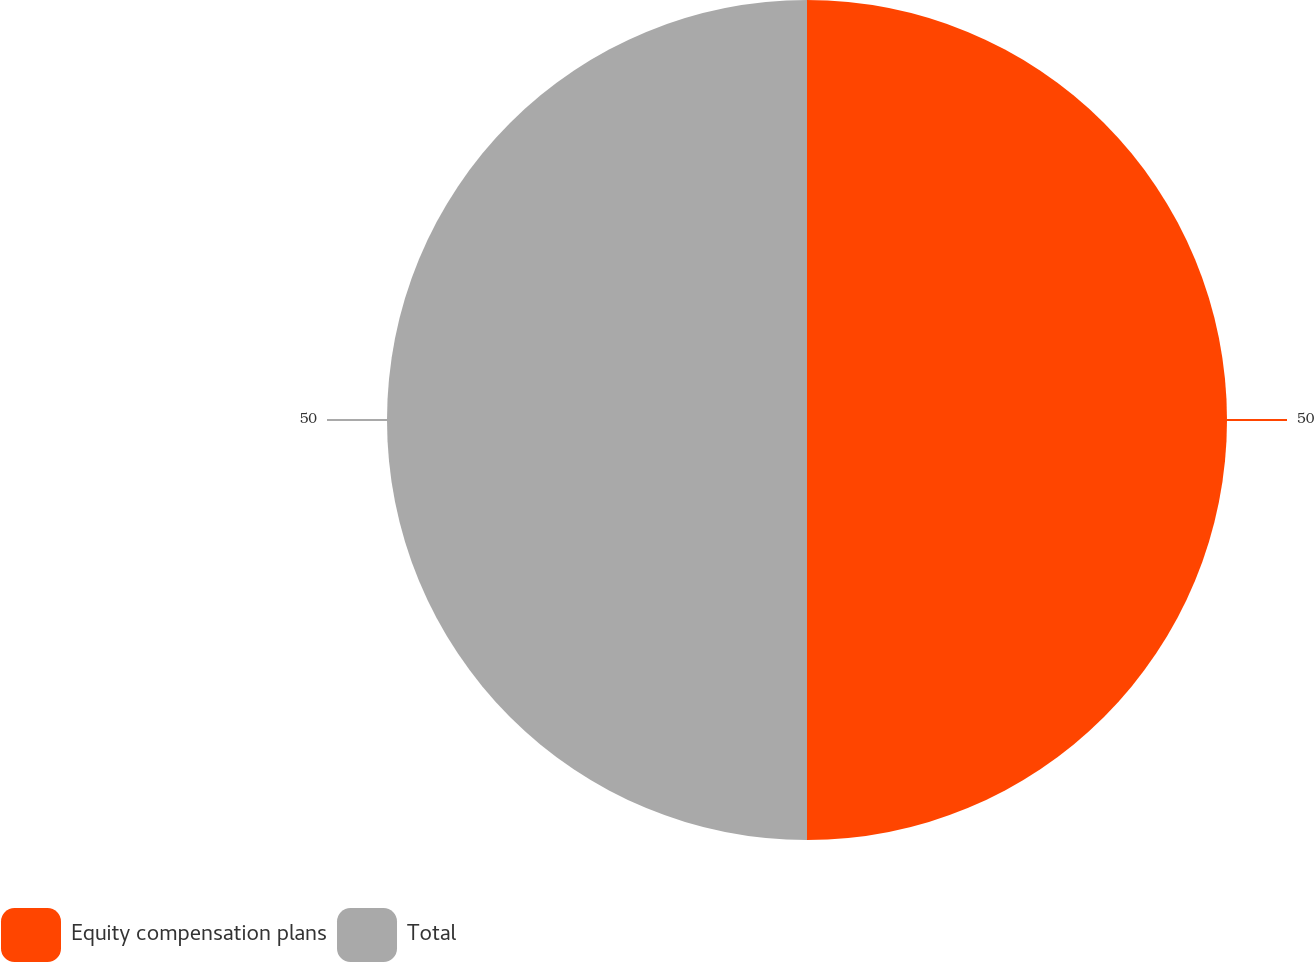Convert chart. <chart><loc_0><loc_0><loc_500><loc_500><pie_chart><fcel>Equity compensation plans<fcel>Total<nl><fcel>50.0%<fcel>50.0%<nl></chart> 